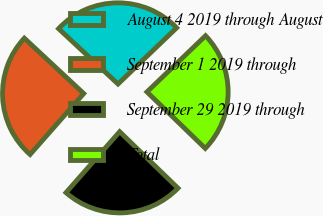Convert chart. <chart><loc_0><loc_0><loc_500><loc_500><pie_chart><fcel>August 4 2019 through August<fcel>September 1 2019 through<fcel>September 29 2019 through<fcel>Total<nl><fcel>25.9%<fcel>25.45%<fcel>24.24%<fcel>24.41%<nl></chart> 